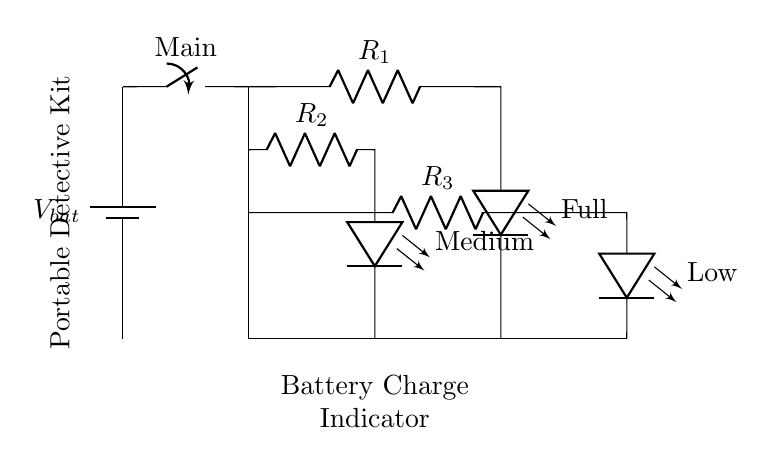What does the circuit indicate? The circuit indicates battery charge levels using LEDs labeled Full, Medium, and Low, which correspond to different resistance values in the current divider.
Answer: Battery charge levels What are the types of components used in this circuit? The components include a battery, switch, resistors, and LEDs. The resistors serve as current dividers, while the LEDs indicate different charge levels.
Answer: Battery, switch, resistors, LEDs How many resistors are present in the circuit? There are three resistors in the circuit, each corresponding to a different LED indicator for the charge levels of the battery.
Answer: Three What is the role of the resistors in this circuit? The resistors create a current divider setup which determines the amount of current flowing through each LED, allowing them to light up based on the battery's charge state.
Answer: Current divider What is the function of the main switch in this circuit? The main switch controls the circuit's power supply, allowing or cutting off the flow of current from the battery to the rest of the components.
Answer: Control power supply 